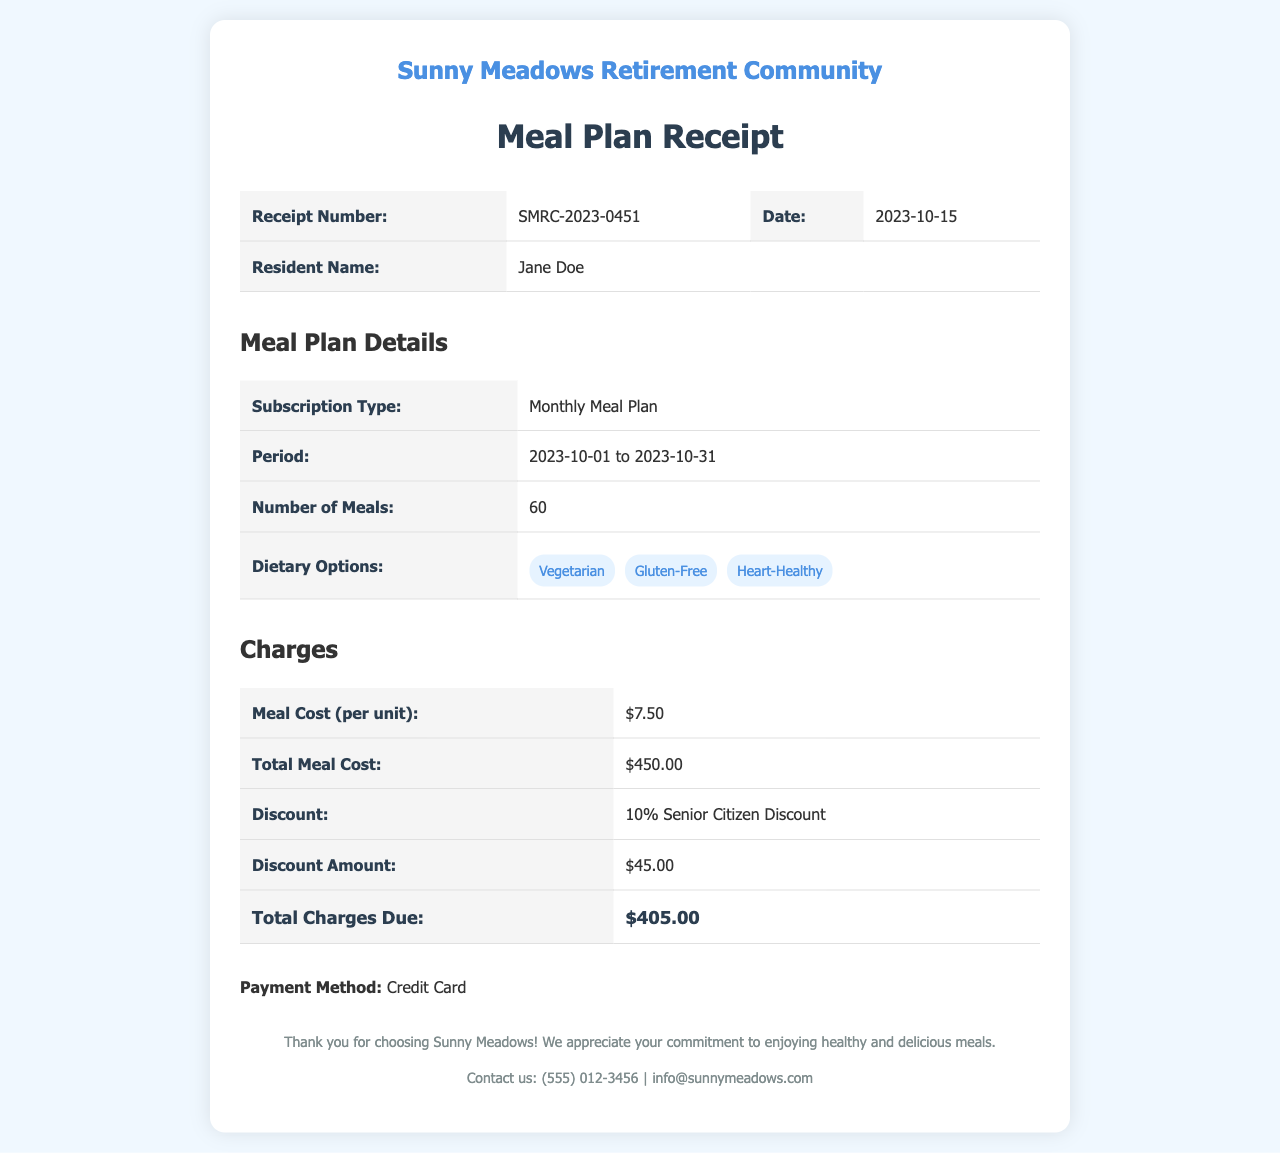What is the receipt number? The receipt number can be found in the receipt details section, which is SMRC-2023-0451.
Answer: SMRC-2023-0451 What is the name of the resident? The resident's name is located in the receipt details section, which states Jane Doe.
Answer: Jane Doe How many meals are included in the plan? The number of meals is listed in the meal plan details as 60.
Answer: 60 What is the total meal cost? The total meal cost is mentioned under the charges details as $450.00.
Answer: $450.00 What is the discount percentage applied? The discount percentage is specified in the charges details as 10%.
Answer: 10% What is the total amount due after discount? The total charges due after applying the discount is listed as $405.00 in the charges details.
Answer: $405.00 What dietary options are selected? The dietary options selected are listed in the meal plan details as Vegetarian, Gluten-Free, and Heart-Healthy.
Answer: Vegetarian, Gluten-Free, Heart-Healthy What payment method was used? The payment method section indicates that a Credit Card was used for the payment.
Answer: Credit Card During which period is the meal plan valid? The validity period of the meal plan is stated as from 2023-10-01 to 2023-10-31.
Answer: 2023-10-01 to 2023-10-31 